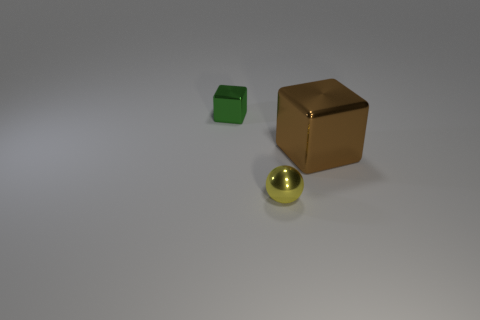Add 3 red spheres. How many objects exist? 6 Subtract all cubes. How many objects are left? 1 Subtract all tiny yellow metal balls. Subtract all big brown cubes. How many objects are left? 1 Add 3 small green shiny things. How many small green shiny things are left? 4 Add 3 small green metallic cubes. How many small green metallic cubes exist? 4 Subtract 0 red blocks. How many objects are left? 3 